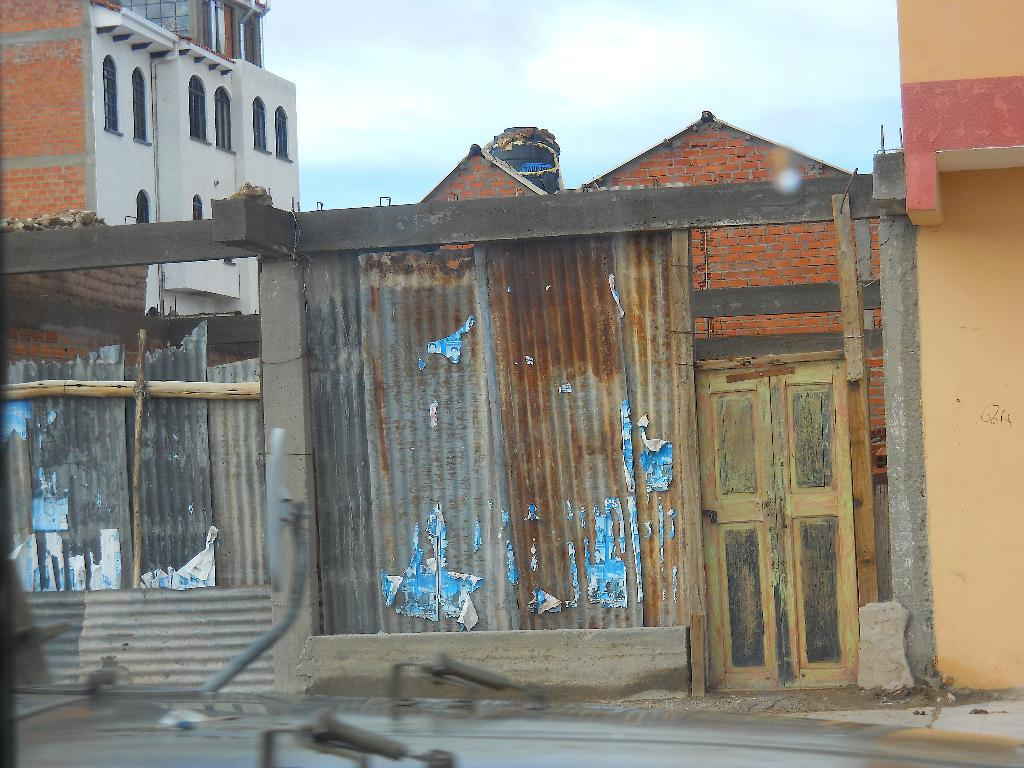What material is present in the image? There are iron sheets in the image. What is the condition of the iron sheets? The iron sheets have some rust. What structure is visible in the image? There is a door in the image. What can be seen in the background of the image? There is a building and the sky visible in the background of the image. What type of needle can be seen in the image? There is no needle present in the image. Is the image depicting a prison scene? There is no indication of a prison in the image; it features iron sheets, a door, a building, and the sky. 